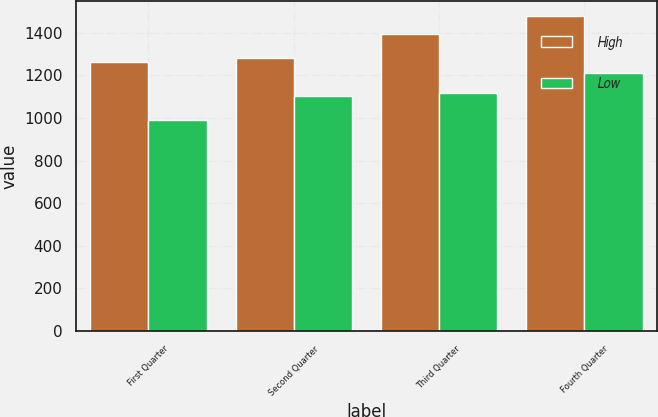<chart> <loc_0><loc_0><loc_500><loc_500><stacked_bar_chart><ecel><fcel>First Quarter<fcel>Second Quarter<fcel>Third Quarter<fcel>Fourth Quarter<nl><fcel>High<fcel>1264<fcel>1280.97<fcel>1395<fcel>1476.52<nl><fcel>Low<fcel>990.69<fcel>1103.45<fcel>1115.77<fcel>1212<nl></chart> 